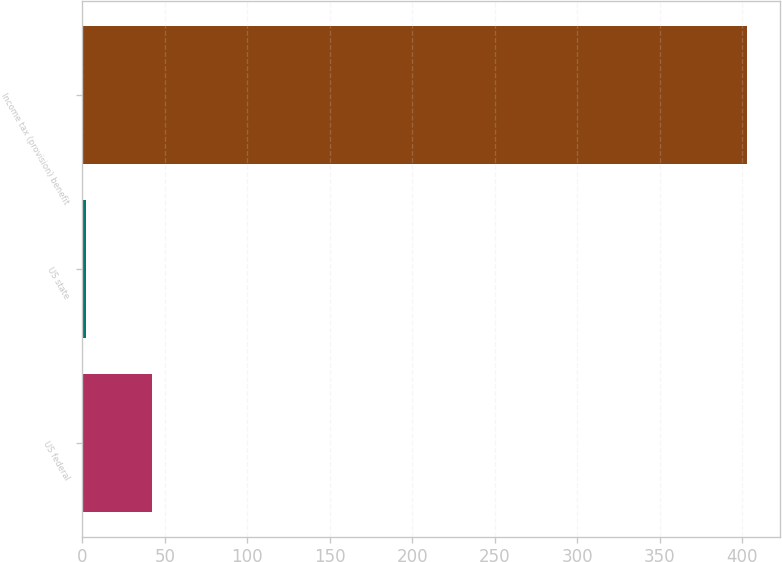Convert chart. <chart><loc_0><loc_0><loc_500><loc_500><bar_chart><fcel>US federal<fcel>US state<fcel>Income tax (provision) benefit<nl><fcel>42.1<fcel>2<fcel>403<nl></chart> 